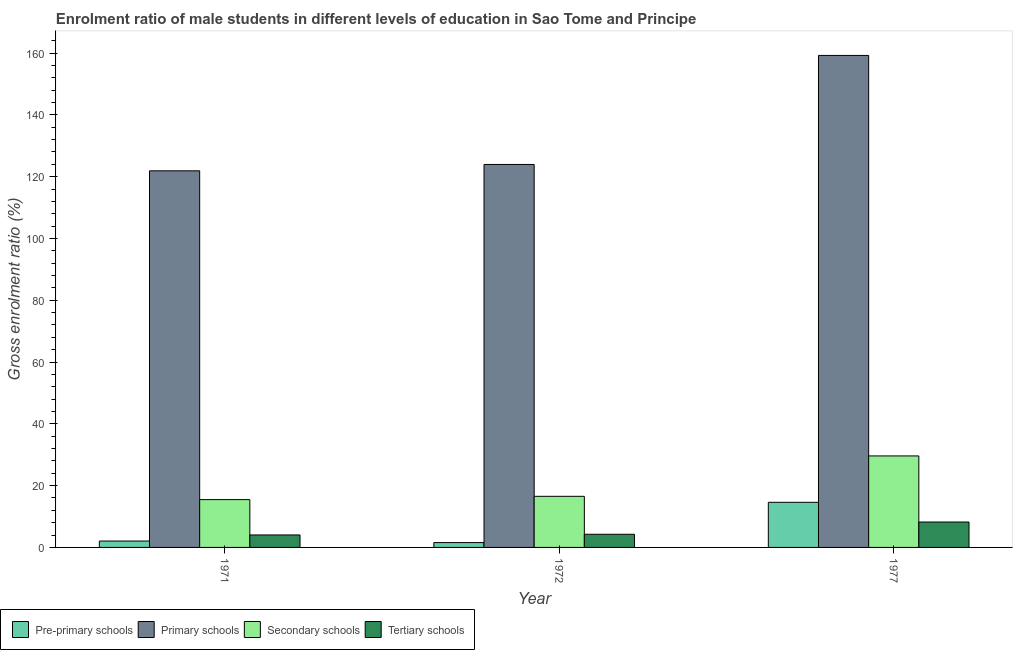How many groups of bars are there?
Make the answer very short. 3. How many bars are there on the 2nd tick from the left?
Give a very brief answer. 4. How many bars are there on the 2nd tick from the right?
Keep it short and to the point. 4. In how many cases, is the number of bars for a given year not equal to the number of legend labels?
Offer a terse response. 0. What is the gross enrolment ratio(female) in primary schools in 1971?
Provide a succinct answer. 121.9. Across all years, what is the maximum gross enrolment ratio(female) in primary schools?
Keep it short and to the point. 159.25. Across all years, what is the minimum gross enrolment ratio(female) in secondary schools?
Offer a terse response. 15.47. In which year was the gross enrolment ratio(female) in secondary schools minimum?
Give a very brief answer. 1971. What is the total gross enrolment ratio(female) in primary schools in the graph?
Make the answer very short. 405.1. What is the difference between the gross enrolment ratio(female) in pre-primary schools in 1972 and that in 1977?
Your response must be concise. -13.04. What is the difference between the gross enrolment ratio(female) in secondary schools in 1977 and the gross enrolment ratio(female) in primary schools in 1972?
Make the answer very short. 13.08. What is the average gross enrolment ratio(female) in pre-primary schools per year?
Offer a terse response. 6.08. What is the ratio of the gross enrolment ratio(female) in tertiary schools in 1972 to that in 1977?
Offer a very short reply. 0.52. What is the difference between the highest and the second highest gross enrolment ratio(female) in pre-primary schools?
Provide a short and direct response. 12.53. What is the difference between the highest and the lowest gross enrolment ratio(female) in tertiary schools?
Your response must be concise. 4.18. In how many years, is the gross enrolment ratio(female) in primary schools greater than the average gross enrolment ratio(female) in primary schools taken over all years?
Provide a short and direct response. 1. Is the sum of the gross enrolment ratio(female) in pre-primary schools in 1971 and 1977 greater than the maximum gross enrolment ratio(female) in tertiary schools across all years?
Provide a short and direct response. Yes. What does the 1st bar from the left in 1971 represents?
Provide a short and direct response. Pre-primary schools. What does the 3rd bar from the right in 1971 represents?
Your answer should be compact. Primary schools. Are all the bars in the graph horizontal?
Keep it short and to the point. No. What is the difference between two consecutive major ticks on the Y-axis?
Your answer should be very brief. 20. Does the graph contain any zero values?
Your answer should be compact. No. How many legend labels are there?
Keep it short and to the point. 4. What is the title of the graph?
Your response must be concise. Enrolment ratio of male students in different levels of education in Sao Tome and Principe. What is the label or title of the Y-axis?
Provide a short and direct response. Gross enrolment ratio (%). What is the Gross enrolment ratio (%) in Pre-primary schools in 1971?
Provide a short and direct response. 2.07. What is the Gross enrolment ratio (%) of Primary schools in 1971?
Offer a terse response. 121.9. What is the Gross enrolment ratio (%) of Secondary schools in 1971?
Your answer should be very brief. 15.47. What is the Gross enrolment ratio (%) in Tertiary schools in 1971?
Your answer should be compact. 4.04. What is the Gross enrolment ratio (%) of Pre-primary schools in 1972?
Ensure brevity in your answer.  1.56. What is the Gross enrolment ratio (%) of Primary schools in 1972?
Your answer should be very brief. 123.95. What is the Gross enrolment ratio (%) of Secondary schools in 1972?
Offer a very short reply. 16.54. What is the Gross enrolment ratio (%) in Tertiary schools in 1972?
Provide a short and direct response. 4.26. What is the Gross enrolment ratio (%) in Pre-primary schools in 1977?
Your answer should be very brief. 14.6. What is the Gross enrolment ratio (%) in Primary schools in 1977?
Give a very brief answer. 159.25. What is the Gross enrolment ratio (%) in Secondary schools in 1977?
Provide a short and direct response. 29.62. What is the Gross enrolment ratio (%) of Tertiary schools in 1977?
Offer a very short reply. 8.22. Across all years, what is the maximum Gross enrolment ratio (%) in Pre-primary schools?
Provide a short and direct response. 14.6. Across all years, what is the maximum Gross enrolment ratio (%) in Primary schools?
Your answer should be compact. 159.25. Across all years, what is the maximum Gross enrolment ratio (%) of Secondary schools?
Offer a very short reply. 29.62. Across all years, what is the maximum Gross enrolment ratio (%) of Tertiary schools?
Provide a succinct answer. 8.22. Across all years, what is the minimum Gross enrolment ratio (%) in Pre-primary schools?
Offer a terse response. 1.56. Across all years, what is the minimum Gross enrolment ratio (%) in Primary schools?
Your response must be concise. 121.9. Across all years, what is the minimum Gross enrolment ratio (%) in Secondary schools?
Give a very brief answer. 15.47. Across all years, what is the minimum Gross enrolment ratio (%) in Tertiary schools?
Your answer should be very brief. 4.04. What is the total Gross enrolment ratio (%) of Pre-primary schools in the graph?
Keep it short and to the point. 18.24. What is the total Gross enrolment ratio (%) in Primary schools in the graph?
Give a very brief answer. 405.1. What is the total Gross enrolment ratio (%) of Secondary schools in the graph?
Your answer should be very brief. 61.63. What is the total Gross enrolment ratio (%) in Tertiary schools in the graph?
Your answer should be compact. 16.52. What is the difference between the Gross enrolment ratio (%) of Pre-primary schools in 1971 and that in 1972?
Provide a succinct answer. 0.5. What is the difference between the Gross enrolment ratio (%) of Primary schools in 1971 and that in 1972?
Your response must be concise. -2.06. What is the difference between the Gross enrolment ratio (%) in Secondary schools in 1971 and that in 1972?
Offer a terse response. -1.07. What is the difference between the Gross enrolment ratio (%) in Tertiary schools in 1971 and that in 1972?
Offer a terse response. -0.22. What is the difference between the Gross enrolment ratio (%) in Pre-primary schools in 1971 and that in 1977?
Your answer should be very brief. -12.53. What is the difference between the Gross enrolment ratio (%) in Primary schools in 1971 and that in 1977?
Ensure brevity in your answer.  -37.35. What is the difference between the Gross enrolment ratio (%) in Secondary schools in 1971 and that in 1977?
Give a very brief answer. -14.14. What is the difference between the Gross enrolment ratio (%) of Tertiary schools in 1971 and that in 1977?
Provide a short and direct response. -4.18. What is the difference between the Gross enrolment ratio (%) in Pre-primary schools in 1972 and that in 1977?
Your answer should be very brief. -13.04. What is the difference between the Gross enrolment ratio (%) in Primary schools in 1972 and that in 1977?
Offer a terse response. -35.29. What is the difference between the Gross enrolment ratio (%) of Secondary schools in 1972 and that in 1977?
Ensure brevity in your answer.  -13.08. What is the difference between the Gross enrolment ratio (%) of Tertiary schools in 1972 and that in 1977?
Make the answer very short. -3.96. What is the difference between the Gross enrolment ratio (%) of Pre-primary schools in 1971 and the Gross enrolment ratio (%) of Primary schools in 1972?
Ensure brevity in your answer.  -121.88. What is the difference between the Gross enrolment ratio (%) of Pre-primary schools in 1971 and the Gross enrolment ratio (%) of Secondary schools in 1972?
Your response must be concise. -14.47. What is the difference between the Gross enrolment ratio (%) of Pre-primary schools in 1971 and the Gross enrolment ratio (%) of Tertiary schools in 1972?
Your response must be concise. -2.19. What is the difference between the Gross enrolment ratio (%) in Primary schools in 1971 and the Gross enrolment ratio (%) in Secondary schools in 1972?
Your response must be concise. 105.35. What is the difference between the Gross enrolment ratio (%) in Primary schools in 1971 and the Gross enrolment ratio (%) in Tertiary schools in 1972?
Make the answer very short. 117.64. What is the difference between the Gross enrolment ratio (%) in Secondary schools in 1971 and the Gross enrolment ratio (%) in Tertiary schools in 1972?
Make the answer very short. 11.22. What is the difference between the Gross enrolment ratio (%) of Pre-primary schools in 1971 and the Gross enrolment ratio (%) of Primary schools in 1977?
Make the answer very short. -157.18. What is the difference between the Gross enrolment ratio (%) of Pre-primary schools in 1971 and the Gross enrolment ratio (%) of Secondary schools in 1977?
Keep it short and to the point. -27.55. What is the difference between the Gross enrolment ratio (%) of Pre-primary schools in 1971 and the Gross enrolment ratio (%) of Tertiary schools in 1977?
Your answer should be compact. -6.15. What is the difference between the Gross enrolment ratio (%) of Primary schools in 1971 and the Gross enrolment ratio (%) of Secondary schools in 1977?
Give a very brief answer. 92.28. What is the difference between the Gross enrolment ratio (%) of Primary schools in 1971 and the Gross enrolment ratio (%) of Tertiary schools in 1977?
Offer a very short reply. 113.67. What is the difference between the Gross enrolment ratio (%) in Secondary schools in 1971 and the Gross enrolment ratio (%) in Tertiary schools in 1977?
Make the answer very short. 7.25. What is the difference between the Gross enrolment ratio (%) in Pre-primary schools in 1972 and the Gross enrolment ratio (%) in Primary schools in 1977?
Your response must be concise. -157.68. What is the difference between the Gross enrolment ratio (%) of Pre-primary schools in 1972 and the Gross enrolment ratio (%) of Secondary schools in 1977?
Your answer should be very brief. -28.05. What is the difference between the Gross enrolment ratio (%) of Pre-primary schools in 1972 and the Gross enrolment ratio (%) of Tertiary schools in 1977?
Your answer should be compact. -6.66. What is the difference between the Gross enrolment ratio (%) of Primary schools in 1972 and the Gross enrolment ratio (%) of Secondary schools in 1977?
Give a very brief answer. 94.34. What is the difference between the Gross enrolment ratio (%) in Primary schools in 1972 and the Gross enrolment ratio (%) in Tertiary schools in 1977?
Your response must be concise. 115.73. What is the difference between the Gross enrolment ratio (%) in Secondary schools in 1972 and the Gross enrolment ratio (%) in Tertiary schools in 1977?
Ensure brevity in your answer.  8.32. What is the average Gross enrolment ratio (%) in Pre-primary schools per year?
Your answer should be compact. 6.08. What is the average Gross enrolment ratio (%) in Primary schools per year?
Your answer should be compact. 135.03. What is the average Gross enrolment ratio (%) in Secondary schools per year?
Give a very brief answer. 20.54. What is the average Gross enrolment ratio (%) of Tertiary schools per year?
Provide a short and direct response. 5.51. In the year 1971, what is the difference between the Gross enrolment ratio (%) in Pre-primary schools and Gross enrolment ratio (%) in Primary schools?
Ensure brevity in your answer.  -119.83. In the year 1971, what is the difference between the Gross enrolment ratio (%) in Pre-primary schools and Gross enrolment ratio (%) in Secondary schools?
Keep it short and to the point. -13.41. In the year 1971, what is the difference between the Gross enrolment ratio (%) of Pre-primary schools and Gross enrolment ratio (%) of Tertiary schools?
Give a very brief answer. -1.97. In the year 1971, what is the difference between the Gross enrolment ratio (%) in Primary schools and Gross enrolment ratio (%) in Secondary schools?
Ensure brevity in your answer.  106.42. In the year 1971, what is the difference between the Gross enrolment ratio (%) of Primary schools and Gross enrolment ratio (%) of Tertiary schools?
Your answer should be compact. 117.86. In the year 1971, what is the difference between the Gross enrolment ratio (%) in Secondary schools and Gross enrolment ratio (%) in Tertiary schools?
Give a very brief answer. 11.43. In the year 1972, what is the difference between the Gross enrolment ratio (%) in Pre-primary schools and Gross enrolment ratio (%) in Primary schools?
Provide a succinct answer. -122.39. In the year 1972, what is the difference between the Gross enrolment ratio (%) of Pre-primary schools and Gross enrolment ratio (%) of Secondary schools?
Ensure brevity in your answer.  -14.98. In the year 1972, what is the difference between the Gross enrolment ratio (%) in Pre-primary schools and Gross enrolment ratio (%) in Tertiary schools?
Offer a very short reply. -2.69. In the year 1972, what is the difference between the Gross enrolment ratio (%) of Primary schools and Gross enrolment ratio (%) of Secondary schools?
Make the answer very short. 107.41. In the year 1972, what is the difference between the Gross enrolment ratio (%) in Primary schools and Gross enrolment ratio (%) in Tertiary schools?
Provide a short and direct response. 119.7. In the year 1972, what is the difference between the Gross enrolment ratio (%) in Secondary schools and Gross enrolment ratio (%) in Tertiary schools?
Keep it short and to the point. 12.28. In the year 1977, what is the difference between the Gross enrolment ratio (%) of Pre-primary schools and Gross enrolment ratio (%) of Primary schools?
Make the answer very short. -144.64. In the year 1977, what is the difference between the Gross enrolment ratio (%) in Pre-primary schools and Gross enrolment ratio (%) in Secondary schools?
Ensure brevity in your answer.  -15.01. In the year 1977, what is the difference between the Gross enrolment ratio (%) in Pre-primary schools and Gross enrolment ratio (%) in Tertiary schools?
Offer a very short reply. 6.38. In the year 1977, what is the difference between the Gross enrolment ratio (%) of Primary schools and Gross enrolment ratio (%) of Secondary schools?
Provide a short and direct response. 129.63. In the year 1977, what is the difference between the Gross enrolment ratio (%) in Primary schools and Gross enrolment ratio (%) in Tertiary schools?
Ensure brevity in your answer.  151.02. In the year 1977, what is the difference between the Gross enrolment ratio (%) in Secondary schools and Gross enrolment ratio (%) in Tertiary schools?
Offer a very short reply. 21.39. What is the ratio of the Gross enrolment ratio (%) of Pre-primary schools in 1971 to that in 1972?
Your answer should be compact. 1.32. What is the ratio of the Gross enrolment ratio (%) in Primary schools in 1971 to that in 1972?
Give a very brief answer. 0.98. What is the ratio of the Gross enrolment ratio (%) in Secondary schools in 1971 to that in 1972?
Ensure brevity in your answer.  0.94. What is the ratio of the Gross enrolment ratio (%) of Tertiary schools in 1971 to that in 1972?
Keep it short and to the point. 0.95. What is the ratio of the Gross enrolment ratio (%) of Pre-primary schools in 1971 to that in 1977?
Offer a very short reply. 0.14. What is the ratio of the Gross enrolment ratio (%) of Primary schools in 1971 to that in 1977?
Make the answer very short. 0.77. What is the ratio of the Gross enrolment ratio (%) in Secondary schools in 1971 to that in 1977?
Keep it short and to the point. 0.52. What is the ratio of the Gross enrolment ratio (%) in Tertiary schools in 1971 to that in 1977?
Offer a very short reply. 0.49. What is the ratio of the Gross enrolment ratio (%) of Pre-primary schools in 1972 to that in 1977?
Ensure brevity in your answer.  0.11. What is the ratio of the Gross enrolment ratio (%) in Primary schools in 1972 to that in 1977?
Your response must be concise. 0.78. What is the ratio of the Gross enrolment ratio (%) of Secondary schools in 1972 to that in 1977?
Provide a short and direct response. 0.56. What is the ratio of the Gross enrolment ratio (%) of Tertiary schools in 1972 to that in 1977?
Provide a short and direct response. 0.52. What is the difference between the highest and the second highest Gross enrolment ratio (%) of Pre-primary schools?
Offer a very short reply. 12.53. What is the difference between the highest and the second highest Gross enrolment ratio (%) in Primary schools?
Offer a terse response. 35.29. What is the difference between the highest and the second highest Gross enrolment ratio (%) in Secondary schools?
Make the answer very short. 13.08. What is the difference between the highest and the second highest Gross enrolment ratio (%) of Tertiary schools?
Ensure brevity in your answer.  3.96. What is the difference between the highest and the lowest Gross enrolment ratio (%) in Pre-primary schools?
Your answer should be very brief. 13.04. What is the difference between the highest and the lowest Gross enrolment ratio (%) of Primary schools?
Make the answer very short. 37.35. What is the difference between the highest and the lowest Gross enrolment ratio (%) of Secondary schools?
Provide a short and direct response. 14.14. What is the difference between the highest and the lowest Gross enrolment ratio (%) of Tertiary schools?
Offer a terse response. 4.18. 